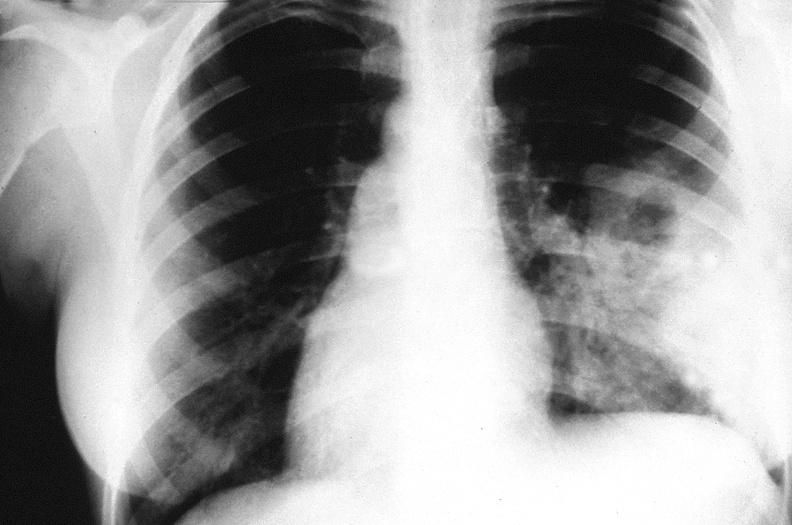what does this image show?
Answer the question using a single word or phrase. Chest x-ray 